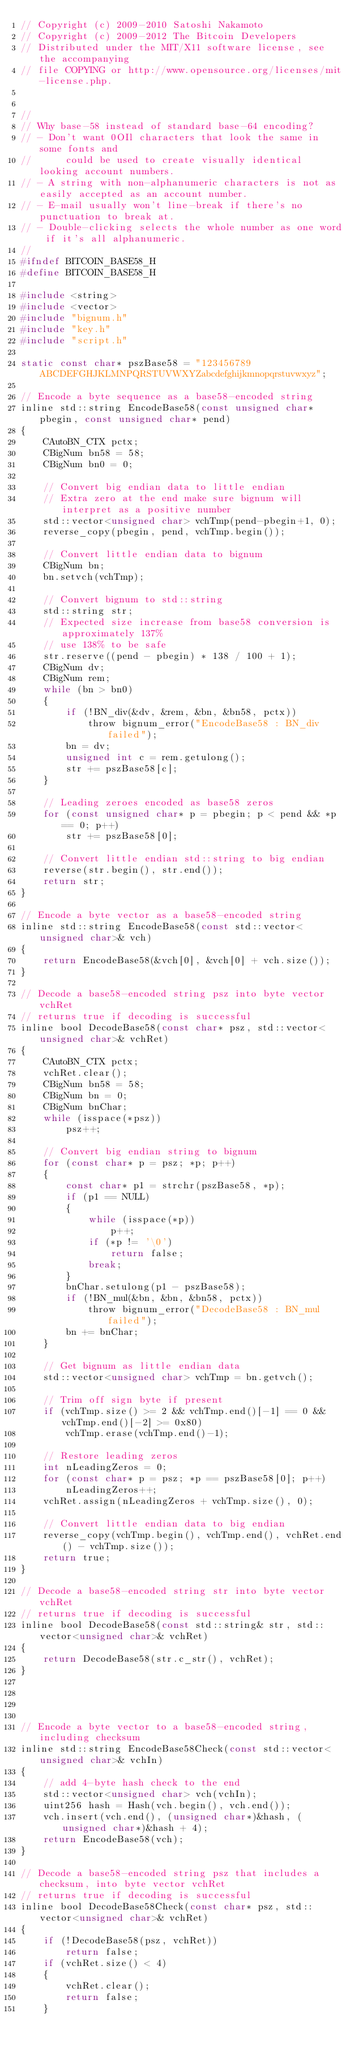<code> <loc_0><loc_0><loc_500><loc_500><_C_>// Copyright (c) 2009-2010 Satoshi Nakamoto
// Copyright (c) 2009-2012 The Bitcoin Developers
// Distributed under the MIT/X11 software license, see the accompanying
// file COPYING or http://www.opensource.org/licenses/mit-license.php.


//
// Why base-58 instead of standard base-64 encoding?
// - Don't want 0OIl characters that look the same in some fonts and
//      could be used to create visually identical looking account numbers.
// - A string with non-alphanumeric characters is not as easily accepted as an account number.
// - E-mail usually won't line-break if there's no punctuation to break at.
// - Double-clicking selects the whole number as one word if it's all alphanumeric.
//
#ifndef BITCOIN_BASE58_H
#define BITCOIN_BASE58_H

#include <string>
#include <vector>
#include "bignum.h"
#include "key.h"
#include "script.h"

static const char* pszBase58 = "123456789ABCDEFGHJKLMNPQRSTUVWXYZabcdefghijkmnopqrstuvwxyz";

// Encode a byte sequence as a base58-encoded string
inline std::string EncodeBase58(const unsigned char* pbegin, const unsigned char* pend)
{
    CAutoBN_CTX pctx;
    CBigNum bn58 = 58;
    CBigNum bn0 = 0;

    // Convert big endian data to little endian
    // Extra zero at the end make sure bignum will interpret as a positive number
    std::vector<unsigned char> vchTmp(pend-pbegin+1, 0);
    reverse_copy(pbegin, pend, vchTmp.begin());

    // Convert little endian data to bignum
    CBigNum bn;
    bn.setvch(vchTmp);

    // Convert bignum to std::string
    std::string str;
    // Expected size increase from base58 conversion is approximately 137%
    // use 138% to be safe
    str.reserve((pend - pbegin) * 138 / 100 + 1);
    CBigNum dv;
    CBigNum rem;
    while (bn > bn0)
    {
        if (!BN_div(&dv, &rem, &bn, &bn58, pctx))
            throw bignum_error("EncodeBase58 : BN_div failed");
        bn = dv;
        unsigned int c = rem.getulong();
        str += pszBase58[c];
    }

    // Leading zeroes encoded as base58 zeros
    for (const unsigned char* p = pbegin; p < pend && *p == 0; p++)
        str += pszBase58[0];

    // Convert little endian std::string to big endian
    reverse(str.begin(), str.end());
    return str;
}

// Encode a byte vector as a base58-encoded string
inline std::string EncodeBase58(const std::vector<unsigned char>& vch)
{
    return EncodeBase58(&vch[0], &vch[0] + vch.size());
}

// Decode a base58-encoded string psz into byte vector vchRet
// returns true if decoding is successful
inline bool DecodeBase58(const char* psz, std::vector<unsigned char>& vchRet)
{
    CAutoBN_CTX pctx;
    vchRet.clear();
    CBigNum bn58 = 58;
    CBigNum bn = 0;
    CBigNum bnChar;
    while (isspace(*psz))
        psz++;

    // Convert big endian string to bignum
    for (const char* p = psz; *p; p++)
    {
        const char* p1 = strchr(pszBase58, *p);
        if (p1 == NULL)
        {
            while (isspace(*p))
                p++;
            if (*p != '\0')
                return false;
            break;
        }
        bnChar.setulong(p1 - pszBase58);
        if (!BN_mul(&bn, &bn, &bn58, pctx))
            throw bignum_error("DecodeBase58 : BN_mul failed");
        bn += bnChar;
    }

    // Get bignum as little endian data
    std::vector<unsigned char> vchTmp = bn.getvch();

    // Trim off sign byte if present
    if (vchTmp.size() >= 2 && vchTmp.end()[-1] == 0 && vchTmp.end()[-2] >= 0x80)
        vchTmp.erase(vchTmp.end()-1);

    // Restore leading zeros
    int nLeadingZeros = 0;
    for (const char* p = psz; *p == pszBase58[0]; p++)
        nLeadingZeros++;
    vchRet.assign(nLeadingZeros + vchTmp.size(), 0);

    // Convert little endian data to big endian
    reverse_copy(vchTmp.begin(), vchTmp.end(), vchRet.end() - vchTmp.size());
    return true;
}

// Decode a base58-encoded string str into byte vector vchRet
// returns true if decoding is successful
inline bool DecodeBase58(const std::string& str, std::vector<unsigned char>& vchRet)
{
    return DecodeBase58(str.c_str(), vchRet);
}




// Encode a byte vector to a base58-encoded string, including checksum
inline std::string EncodeBase58Check(const std::vector<unsigned char>& vchIn)
{
    // add 4-byte hash check to the end
    std::vector<unsigned char> vch(vchIn);
    uint256 hash = Hash(vch.begin(), vch.end());
    vch.insert(vch.end(), (unsigned char*)&hash, (unsigned char*)&hash + 4);
    return EncodeBase58(vch);
}

// Decode a base58-encoded string psz that includes a checksum, into byte vector vchRet
// returns true if decoding is successful
inline bool DecodeBase58Check(const char* psz, std::vector<unsigned char>& vchRet)
{
    if (!DecodeBase58(psz, vchRet))
        return false;
    if (vchRet.size() < 4)
    {
        vchRet.clear();
        return false;
    }</code> 